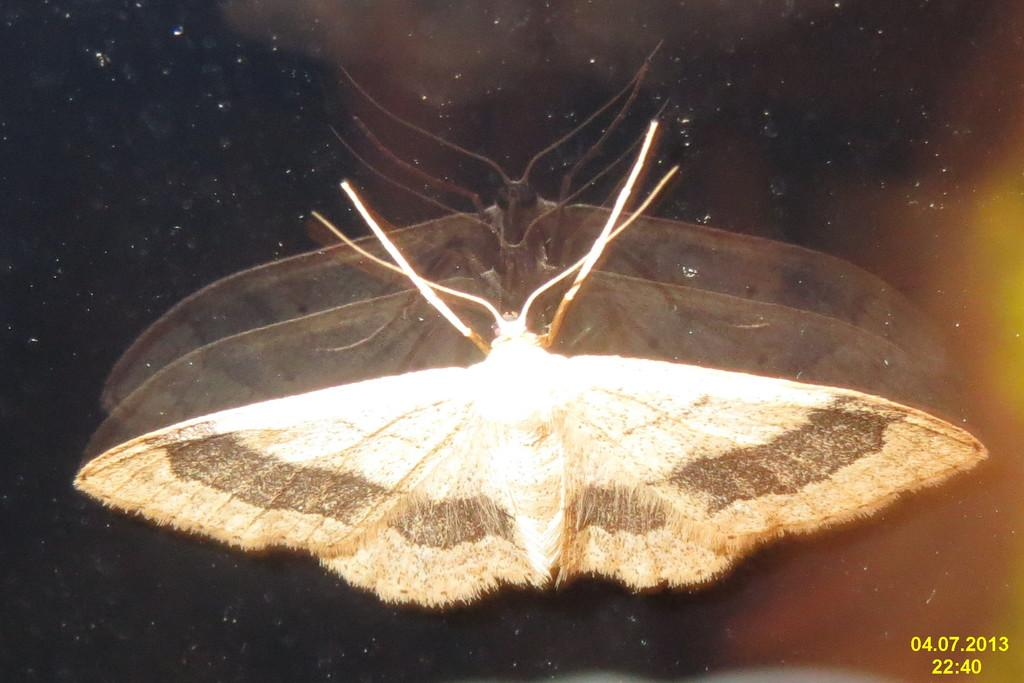What is the main subject of the image? There is a fly in the center of the image. What can be observed about the background of the image? The background of the image is dark. Where is the light source located in the image? The light is on the right side of the image. What else can be seen on the right side of the image? Some text is present on the right side of the image. What type of mark can be seen on the fly's neck in the image? There is no mark on the fly's neck in the image, as flies do not have necks. 